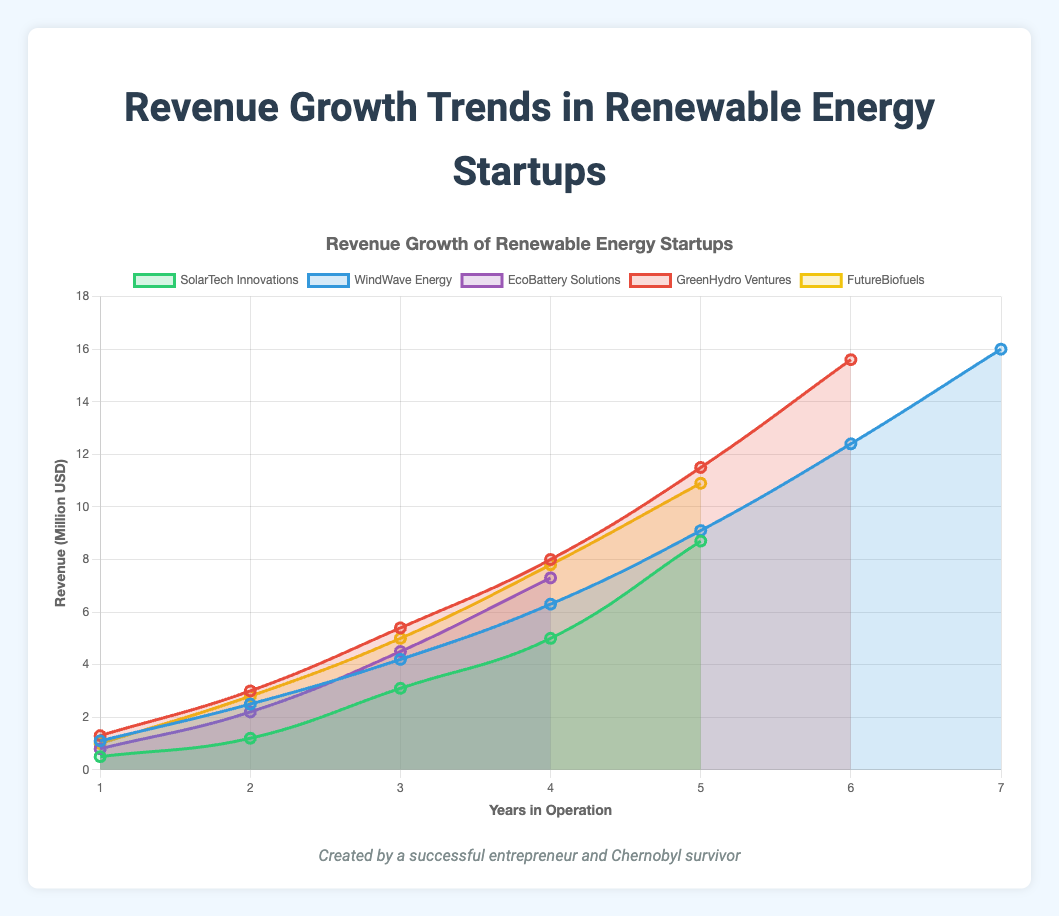What is the average annual revenue of SolarTech Innovations over 5 years? Sum of SolarTech Innovations' annual revenue over 5 years is (0.5 + 1.2 + 3.1 + 5.0 + 8.7) = 18.5 million USD. The average is 18.5 / 5 = 3.7 million USD.
Answer: 3.7 million USD Which startup has the highest revenue after 4 years of operation? After 4 years, the revenues for each startup are: SolarTech Innovations: 5.0 million USD, WindWave Energy: 6.3 million USD, EcoBattery Solutions: 7.3 million USD, GreenHydro Ventures: 8.0 million USD, FutureBiofuels: 7.8 million USD. GreenHydro Ventures has the highest revenue after 4 years.
Answer: GreenHydro Ventures How much more revenue does WindWave Energy have in its 7th year compared to its 3rd year? WindWave Energy's revenue in the 7th year is 16.0 million USD and in the 3rd year is 4.2 million USD. The difference is 16.0 - 4.2 = 11.8 million USD.
Answer: 11.8 million USD Which startup shows the steepest revenue growth between any two consecutive years? Comparing the revenue growth between consecutive years shows: SolarTech Innovations (year 4-5): 3.7 million USD, WindWave Energy (year 6-7): 3.6 million USD, EcoBattery Solutions (year 3-4): 2.8 million USD, GreenHydro Ventures (year 5-6): 4.1 million USD, FutureBiofuels (year 4-5): 3.1 million USD. GreenHydro Ventures shows the steepest growth between years 5-6 with 4.1 million USD.
Answer: GreenHydro Ventures Between which years did FutureBiofuels see the largest increase in revenue? Examining the revenue increases for FutureBiofuels: year 1-2: 1.8 million USD, year 2-3: 2.2 million USD, year 3-4: 2.8 million USD, year 4-5: 3.1 million USD. The largest increase is between years 4 and 5 with a 3.1 million USD increase.
Answer: Between years 4 and 5 What is the total revenue generated by EcoBattery Solutions over 4 years? Sum of EcoBattery Solutions' annual revenue over 4 years is (0.8 + 2.2 + 4.5 + 7.3) = 14.8 million USD.
Answer: 14.8 million USD Which startup had the lowest initial revenue in their first year of operation? Looking at the initial revenues: SolarTech Innovations: 0.5 million USD, WindWave Energy: 1.1 million USD, EcoBattery Solutions: 0.8 million USD, GreenHydro Ventures: 1.3 million USD, FutureBiofuels: 1.0 million USD. SolarTech Innovations had the lowest initial revenue at 0.5 million USD.
Answer: SolarTech Innovations Compare the revenue growth of EcoBattery Solutions and FutureBiofuels in their third year. Which one performed better? In year three, EcoBattery Solutions had a revenue of 4.5 million USD, and FutureBiofuels had 5.0 million USD. FutureBiofuels performed better with 0.5 million USD more revenue.
Answer: FutureBiofuels 